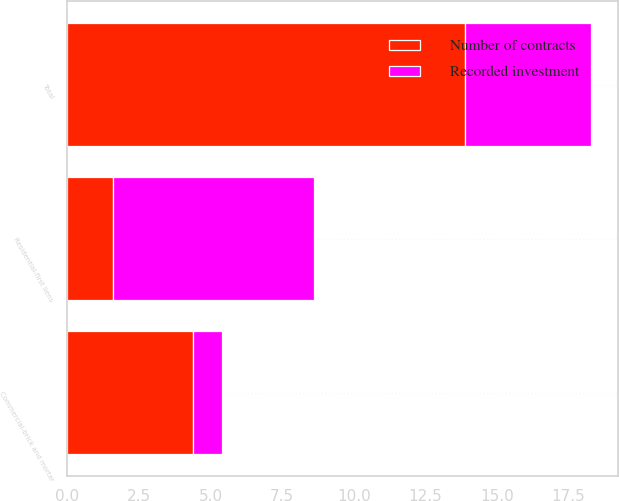Convert chart. <chart><loc_0><loc_0><loc_500><loc_500><stacked_bar_chart><ecel><fcel>Commercial-brick and mortar<fcel>Residential-first liens<fcel>Total<nl><fcel>Recorded investment<fcel>1<fcel>7<fcel>4.4<nl><fcel>Number of contracts<fcel>4.4<fcel>1.6<fcel>13.9<nl></chart> 